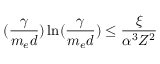Convert formula to latex. <formula><loc_0><loc_0><loc_500><loc_500>( \frac { \gamma } { m _ { e } d } ) \ln ( \frac { \gamma } { m _ { e } d } ) \leq \frac { \xi } { \alpha ^ { 3 } Z ^ { 2 } }</formula> 